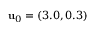Convert formula to latex. <formula><loc_0><loc_0><loc_500><loc_500>{ u } _ { 0 } = ( 3 . 0 , 0 . 3 )</formula> 